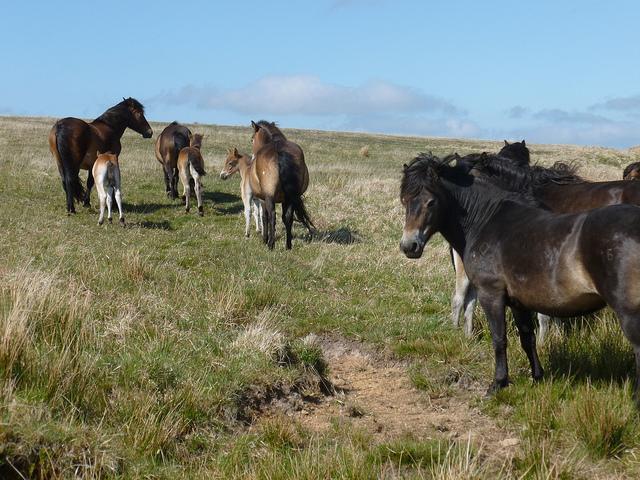How many animals are shown here?
Give a very brief answer. 9. How many horses are there?
Give a very brief answer. 4. 